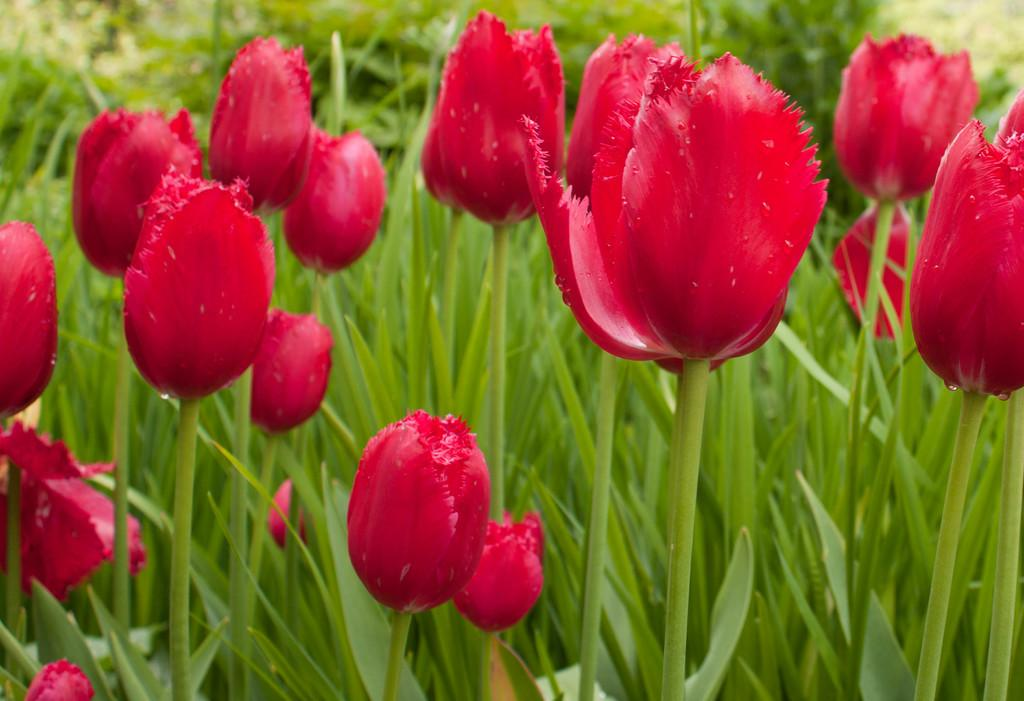What type of plants can be seen in the image? There are grass plants in the image. What kind of flowers are present in the image? There are tulip flowers in the image. What is the color of the tulip flowers? The tulip flowers are red in color. How much does the sugar cost in the image? There is no sugar present in the image, so it is not possible to determine its cost. 